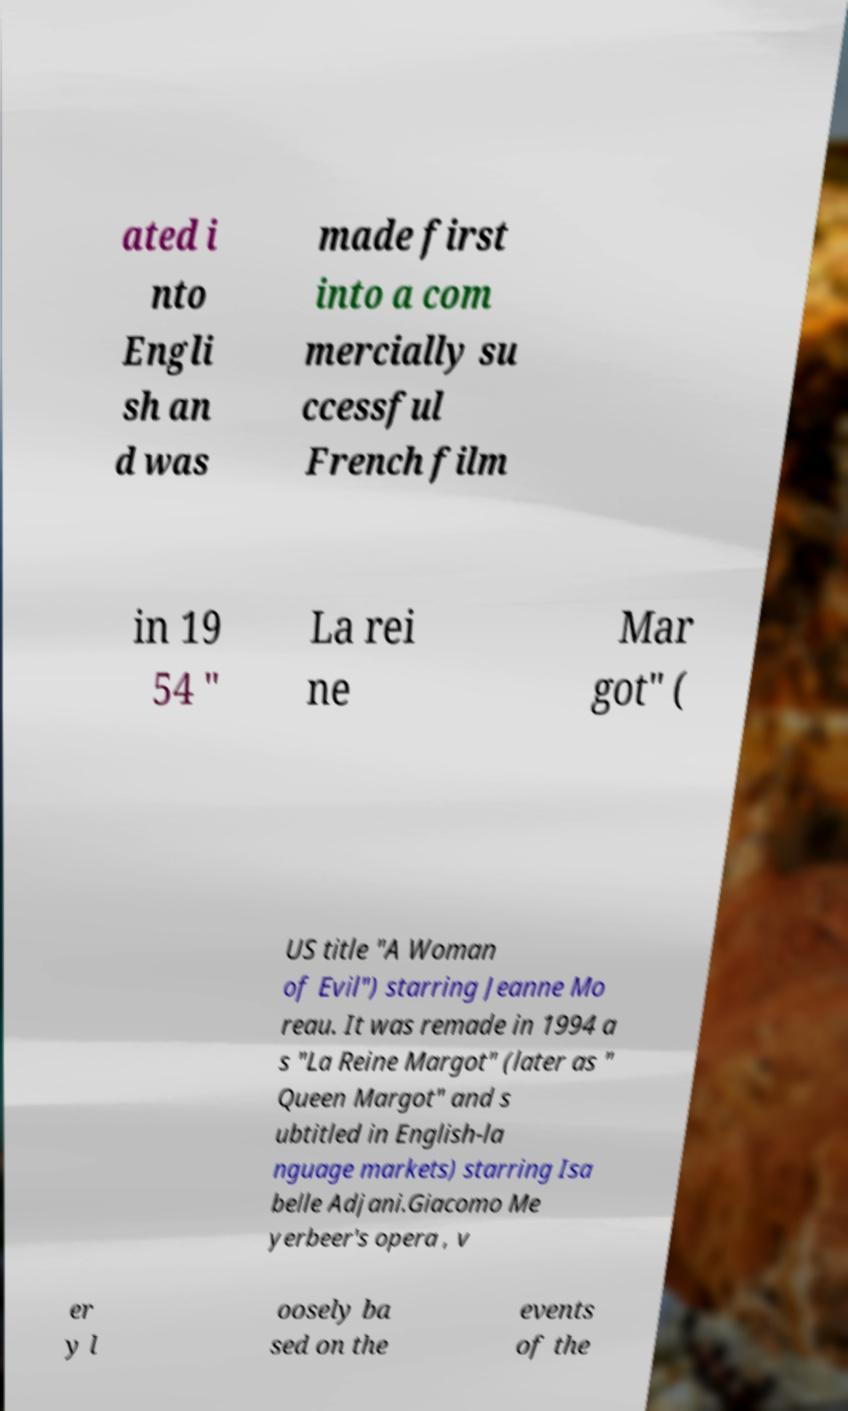Can you accurately transcribe the text from the provided image for me? ated i nto Engli sh an d was made first into a com mercially su ccessful French film in 19 54 " La rei ne Mar got" ( US title "A Woman of Evil") starring Jeanne Mo reau. It was remade in 1994 a s "La Reine Margot" (later as " Queen Margot" and s ubtitled in English-la nguage markets) starring Isa belle Adjani.Giacomo Me yerbeer's opera , v er y l oosely ba sed on the events of the 